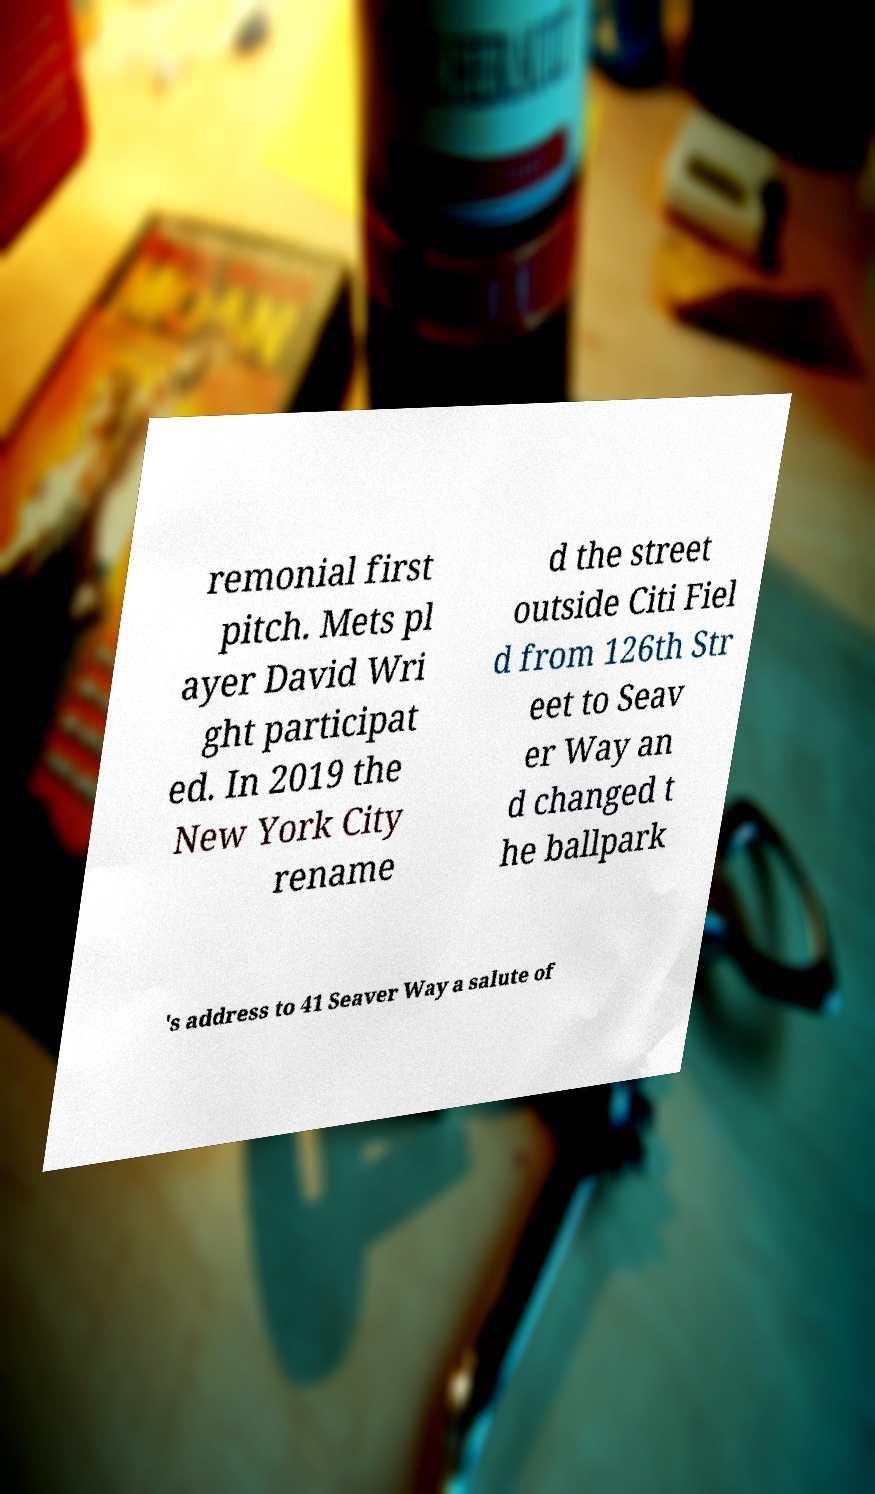I need the written content from this picture converted into text. Can you do that? remonial first pitch. Mets pl ayer David Wri ght participat ed. In 2019 the New York City rename d the street outside Citi Fiel d from 126th Str eet to Seav er Way an d changed t he ballpark 's address to 41 Seaver Way a salute of 